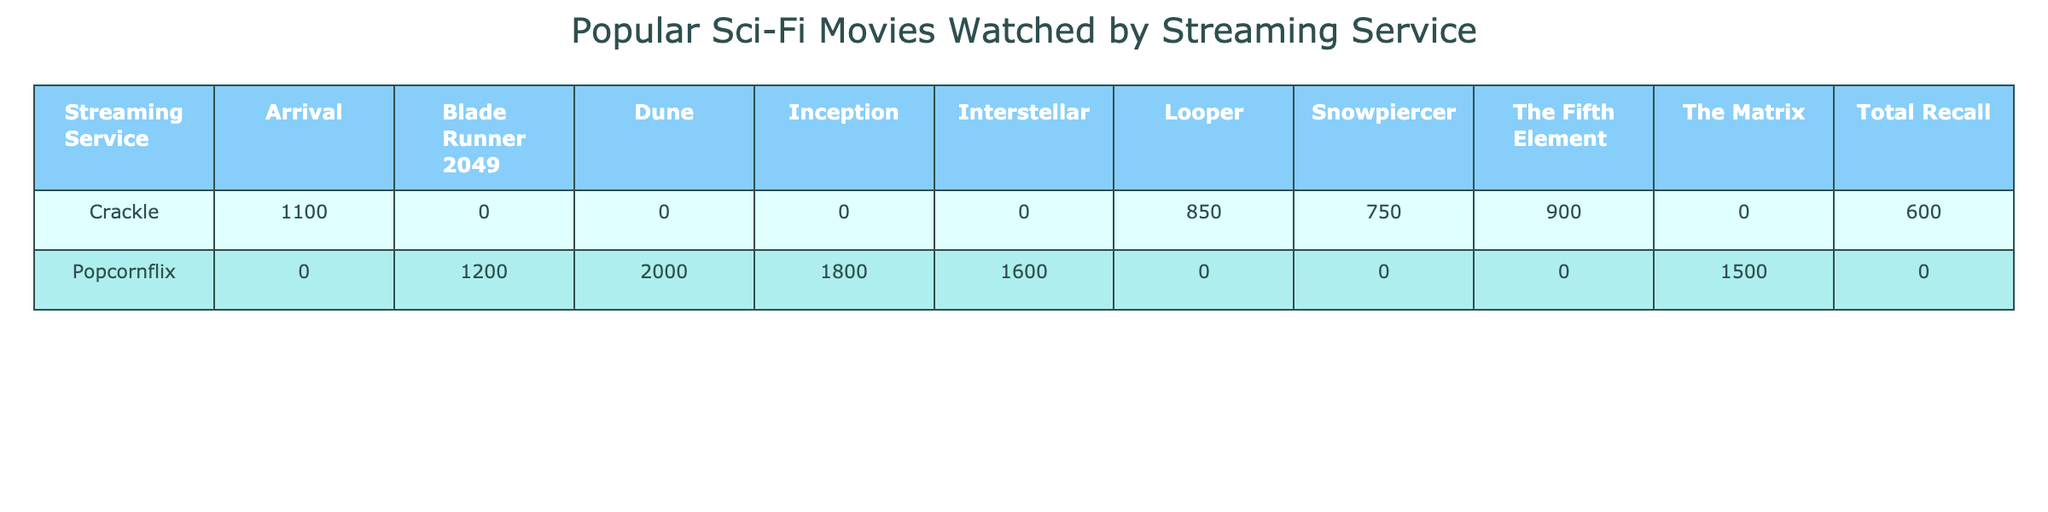What is the most-watched movie on Popcornflix? According to the table, the movie with the highest watch count on Popcornflix is "Dune" with 2000 views.
Answer: Dune How many movies are listed for Crackle? There are five movies listed under Crackle: "The Fifth Element," "Looper," "Arrival," "Snowpiercer," and "Total Recall." Counting these, we find a total of 5 movies.
Answer: 5 Which director has the highest total watch count across both streaming services? First, we summarize the watch counts per director: The Wachowskis (1500), Denis Villeneuve (1200 + 1100 + 2000 = 4300), Christopher Nolan (1800 + 1600 = 3400), Luc Besson (900), Rian Johnson (850), Bong Joon-ho (750), and Paul Verhoeven (600). Denis Villeneuve has the highest total with 4300 views.
Answer: Denis Villeneuve Is the movie "Interstellar" available on Crackle? Referring to the data in the table, "Interstellar" is listed under Popcornflix and is not included in the Crackle movies. Therefore, the answer is no.
Answer: No What is the average watch count for the movies listed under Popcornflix? The movies on Popcornflix and their watch counts are: "The Matrix" (1500), "Blade Runner 2049" (1200), "Inception" (1800), "Interstellar" (1600), and "Dune" (2000). Adding these gives 1500 + 1200 + 1800 + 1600 + 2000 = 9100. Dividing this sum by the number of movies (5) results in an average of 9100 / 5 = 1820.
Answer: 1820 What is the total watch count of all Sci-Fi movies on Crackle? The individual movies and their watch counts on Crackle are: "The Fifth Element" (900), "Looper" (850), "Arrival" (1100), "Snowpiercer" (750), and "Total Recall" (600). Summing these gives 900 + 850 + 1100 + 750 + 600 = 4200.
Answer: 4200 Which movie has the lowest watch count on Crackle? The movies on Crackle and their watch counts are: "The Fifth Element" (900), "Looper" (850), "Arrival" (1100), "Snowpiercer" (750), and "Total Recall" (600). The movie with the lowest watch count is "Total Recall" with 600 views.
Answer: Total Recall Which streaming service has more total views for its movies? Popcornflix total views are: 1500 + 1200 + 1800 + 1600 + 2000 = 9100. Crackle total views are: 900 + 850 + 1100 + 750 + 600 = 4200. Since 9100 (Popcornflix) is greater than 4200 (Crackle), Popcornflix has more total views.
Answer: Popcornflix 